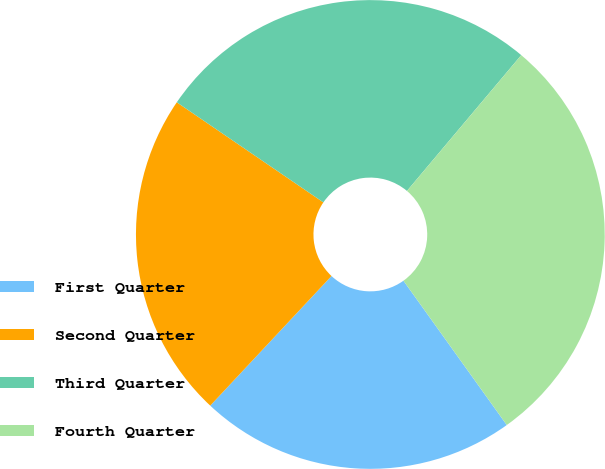Convert chart to OTSL. <chart><loc_0><loc_0><loc_500><loc_500><pie_chart><fcel>First Quarter<fcel>Second Quarter<fcel>Third Quarter<fcel>Fourth Quarter<nl><fcel>21.86%<fcel>22.57%<fcel>26.6%<fcel>28.98%<nl></chart> 